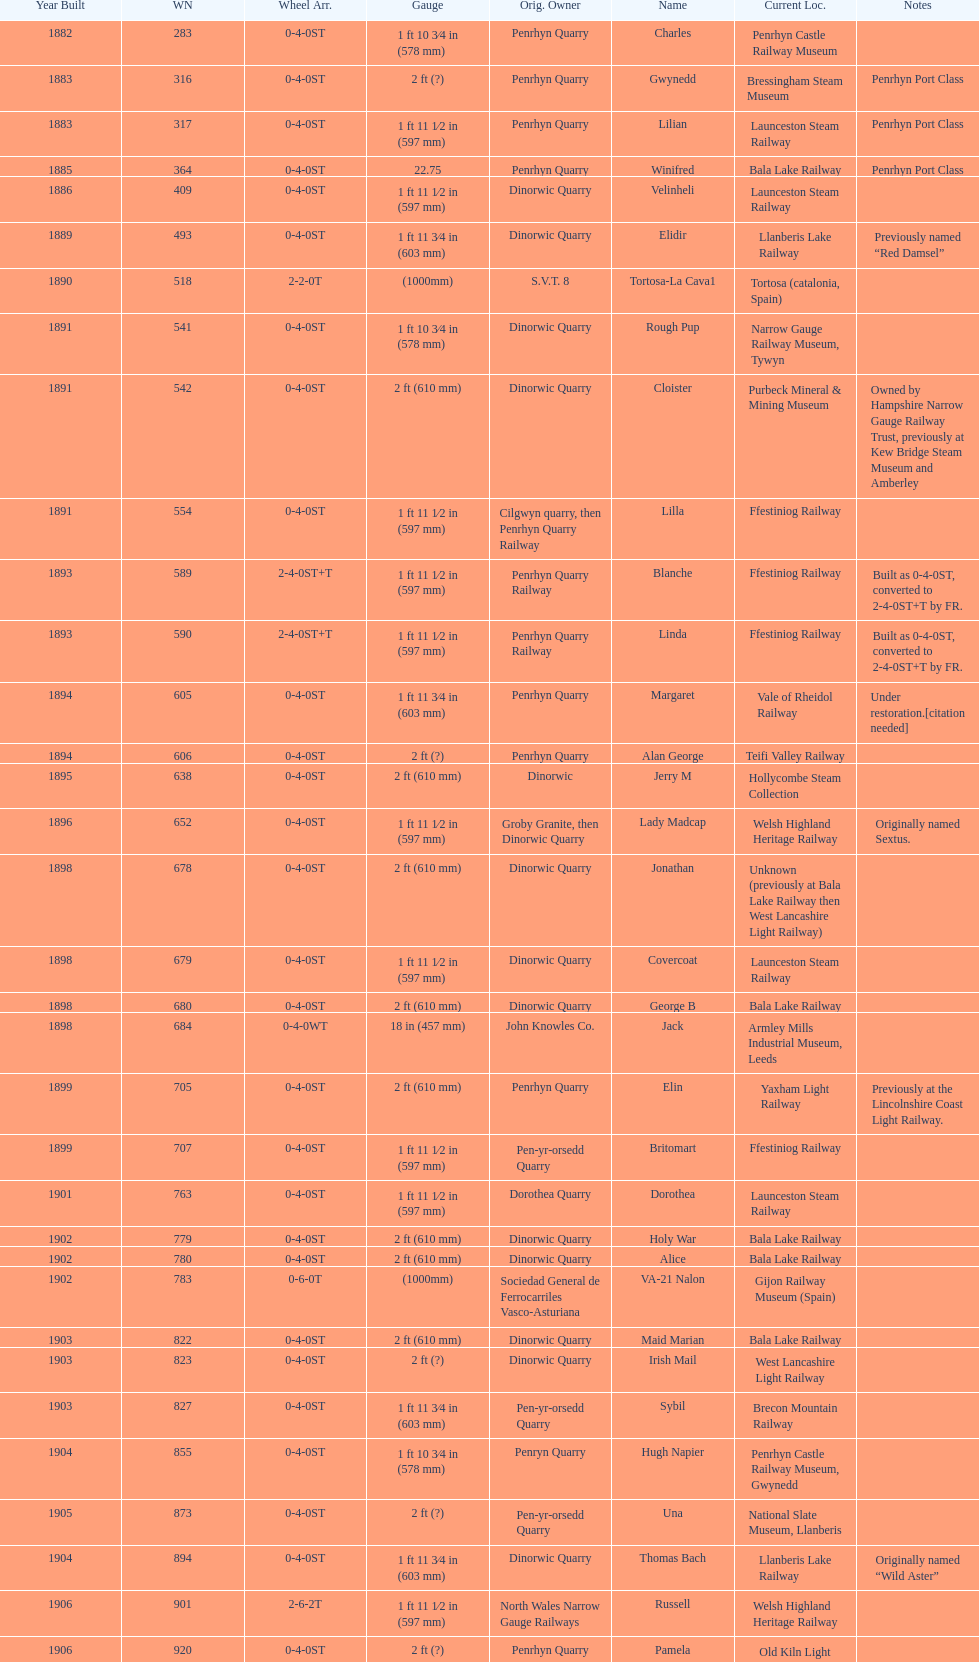In which year were the most steam locomotives built? 1898. 